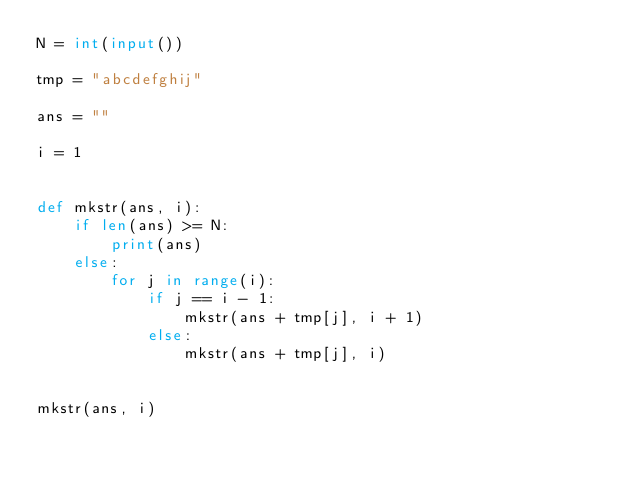Convert code to text. <code><loc_0><loc_0><loc_500><loc_500><_Python_>N = int(input())

tmp = "abcdefghij"

ans = ""

i = 1


def mkstr(ans, i):
    if len(ans) >= N:
        print(ans)
    else:
        for j in range(i):
            if j == i - 1:
                mkstr(ans + tmp[j], i + 1)
            else:
                mkstr(ans + tmp[j], i)


mkstr(ans, i)
</code> 